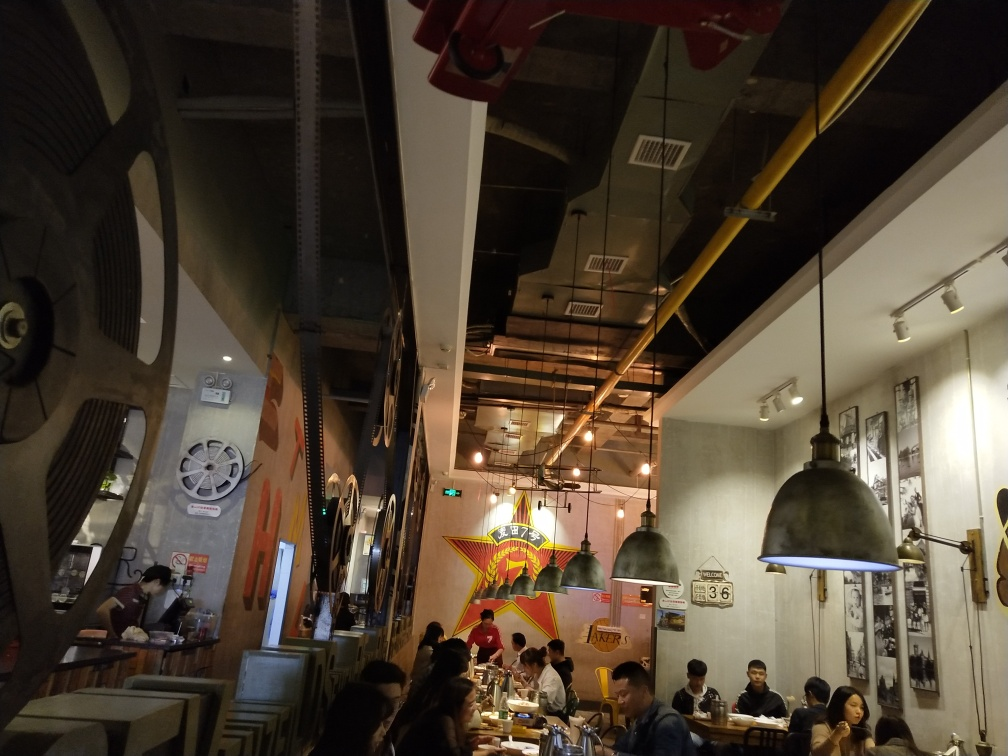Are there any distinctive decorations in the restaurant that stand out? Yes, there are several notable decorations within this restaurant that catch the eye. A large, colorful mural is visible in the back, likely an artistic focal point, alongside propeller-like wall elements and film reel motifs. These elements, along with the choice of industrial lighting fixtures, contribute to a distinctive, possibly aviation or film-themed atmosphere. 